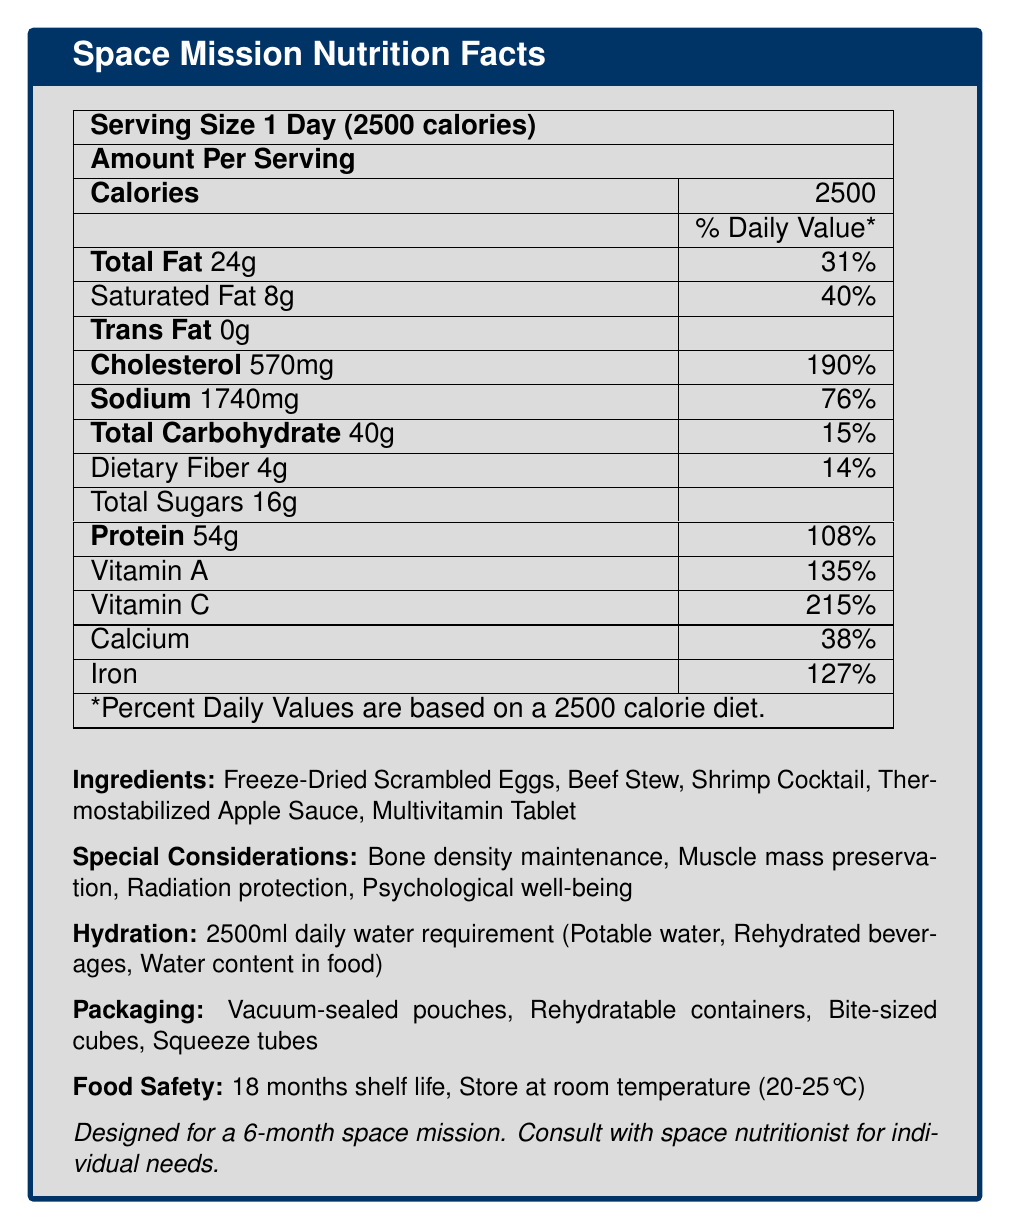what is the daily caloric requirement for the mission? The document states a "daily caloric requirement" of 2500 calories for the mission.
Answer: 2500 calories what are the meal types included in the nutrition plan? The document lists "meal_types" as "Breakfast," "Lunch," "Dinner," and "Snacks."
Answer: Breakfast, Lunch, Dinner, Snacks which food item has the highest amount of protein per serving? According to the document, "Shrimp Cocktail" has 20g of protein per serving, which is the highest among the food items listed.
Answer: Shrimp Cocktail how much sodium is in a serving of Beef Stew? The "food_items" section shows that Beef Stew contains 890mg of sodium per serving.
Answer: 890mg what is the serving size of Thermostabilized Apple Sauce? The document states that the serving size for Thermostabilized Apple Sauce is 113g.
Answer: 113g how many days is the mission duration? The document lists the "mission_duration_days" as 180, which corresponds to six months.
Answer: 180 days what percentage of the daily value for Vitamin A is provided per serving? The "Space Mission Nutrition Facts" table indicates that each serving provides 135% of the daily value for Vitamin A.
Answer: 135% which food item provides the most vitamin C? According to the data, Thermostabilized Apple Sauce provides 100% of the daily value for Vitamin C per serving.
Answer: Thermostabilized Apple Sauce what is the shelf life of the food items? The "Food Safety" section of the document states that the shelf life is 18 months.
Answer: 18 months which food packaging method is NOT listed as one of the options? A. Vacuum-sealed pouches B. Rehydratable containers C. Tin cans D. Bite-sized cubes The document lists "Vacuum-sealed pouches," "Rehydratable containers," and "Bite-sized cubes" but does not mention "Tin cans."
Answer: C. Tin cans how much calcium does the Multivitamin Tablet provide? A. 10% B. 20% C. 50% D. 100% The nutrition data for the Multivitamin Tablet indicates it provides 20% of the daily value for calcium.
Answer: B. 20% does the hydration section recommend a daily water intake? The document states a "daily water requirement" of 2500ml, which is part of the hydration plan.
Answer: Yes summarize the main nutritional aspects covered for the mission. The document outlines a comprehensive nutrition plan for a long-duration space mission, ensuring astronauts receive balanced nutrition and hydration, addressing various health concerns, and specifying packaging and safety measures.
Answer: The document provides nutritional guidelines for a 6-month space mission, detailing daily caloric and water requirements, food items, and their nutritional values. It includes special considerations for bone density, muscle mass, radiation protection, and psychological well-being. The food is packaged in vacuum-sealed pouches, rehydratable containers, bite-sized cubes, and squeeze tubes, with an 18-month shelf life. what type of food packaging needs to be avoided to prevent crumbs in microgravity? The document mentions "Crumb control" as a concern but does not specify which packaging type should be avoided to prevent crumbs in microgravity.
Answer: Not enough information 